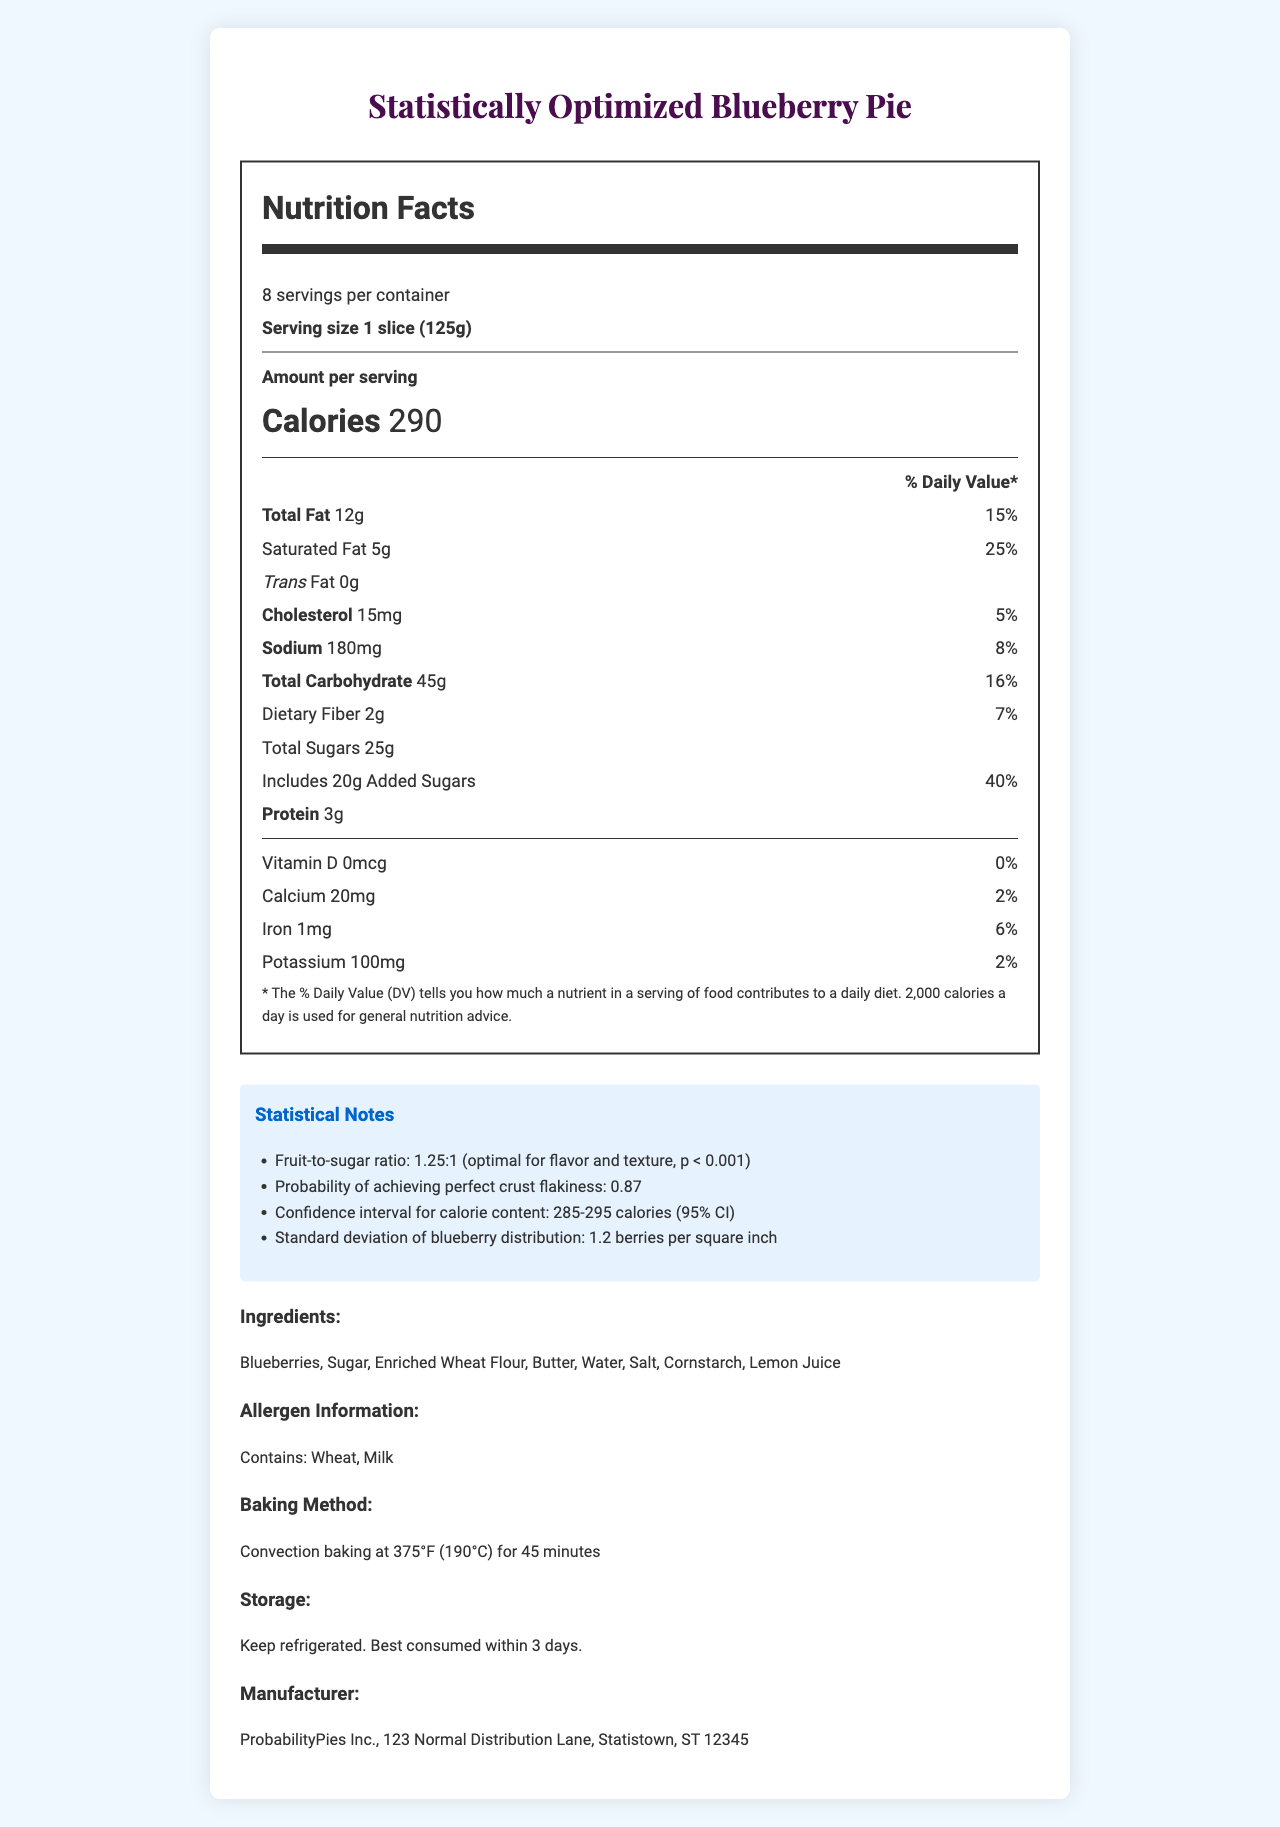what is the serving size? The document mentions "Serving size: 1 slice (125g)" which indicates the serving size.
Answer: 1 slice (125g) how many calories are there per serving? The document states "Calories: 290" under the nutrition facts.
Answer: 290 how much total fat is in one serving? The nutrition label specifies "Total Fat: 12g".
Answer: 12g how much dietary fiber does each serving contain? The label under "Total Carbohydrate" indicates "Dietary Fiber: 2g".
Answer: 2g what is the probability of achieving perfect crust flakiness? The statistical notes mention the probability of achieving perfect crust flakiness as 0.87.
Answer: 0.87 how many added sugars are in a serving? The document states "Includes 20g Added Sugars" under the "Total Sugars" section.
Answer: 20g the fruit-to-sugar ratio is described as optimal for flavor and texture with what level of statistical significance? The statistical notes specify "Fruit-to-sugar ratio: 1.25:1 (optimal for flavor and texture, p < 0.001)".
Answer: p < 0.001 how many servings are there per container? The document mentions "8 servings per container".
Answer: 8 what is the standard deviation of blueberry distribution? The statistical notes state "Standard deviation of blueberry distribution: 1.2 berries per square inch".
Answer: 1.2 berries per square inch what is the daily value percentage of saturated fat per serving? A. 20% B. 25% C. 30% The document shows "Saturated Fat: 5g" with a daily value of 25%.
Answer: B. 25% which of the following ingredients is not listed in the pie? A. Blueberries B. Sugar C. Eggs D. Butter The list of ingredients includes blueberries, sugar, and butter, but not eggs.
Answer: C. Eggs does this product contain milk? The allergen information states "Contains: Wheat, Milk".
Answer: Yes is vitamin D present in this product? The document states "Vitamin D: 0mcg (0%)", indicating no vitamin D is present in this product.
Answer: No summarize the main nutritional details for the Statistically Optimized Blueberry Pie. The main nutritional details provided cover calories, fat, sodium, carbohydrates, protein, and essential vitamins and minerals per serving, highlighting significant nutritional components and their respective amounts.
Answer: The Statistically Optimized Blueberry Pie contains 290 calories per slice with 8 servings per container. It has 12g of total fat, 5g of saturated fat, and 0g trans fat. The pie includes 180mg of sodium, 45g of total carbohydrate, 2g of dietary fiber, and 25g of total sugars (including 20g of added sugars). Additionally, it provides 3g of protein and various vitamins and minerals such as calcium, iron, and potassium. what are the detailed steps to prepare this pie? The document provides the baking temperature and time (375°F for 45 minutes) but does not detail the preparation steps or methods.
Answer: Not enough information is there any iron content listed for this product? The document indicates that there is 1mg of iron per serving (6% daily value).
Answer: Yes 